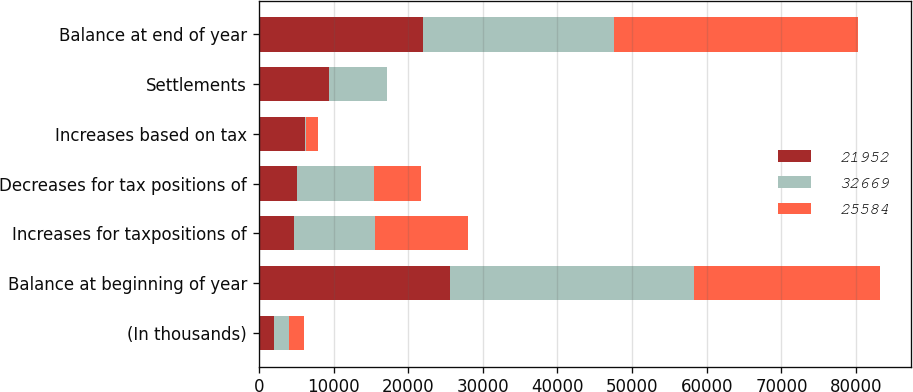Convert chart. <chart><loc_0><loc_0><loc_500><loc_500><stacked_bar_chart><ecel><fcel>(In thousands)<fcel>Balance at beginning of year<fcel>Increases for taxpositions of<fcel>Decreases for tax positions of<fcel>Increases based on tax<fcel>Settlements<fcel>Balance at end of year<nl><fcel>21952<fcel>2010<fcel>25584<fcel>4756<fcel>5114<fcel>6186<fcel>9460<fcel>21952<nl><fcel>32669<fcel>2009<fcel>32669<fcel>10757<fcel>10265<fcel>136<fcel>7713<fcel>25584<nl><fcel>25584<fcel>2008<fcel>24957<fcel>12485<fcel>6321<fcel>1608<fcel>60<fcel>32669<nl></chart> 